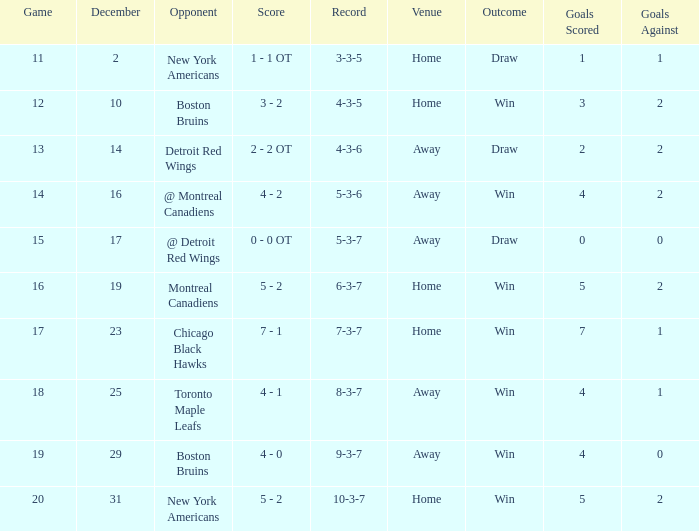Which Score has a December smaller than 14, and a Game of 12? 3 - 2. 